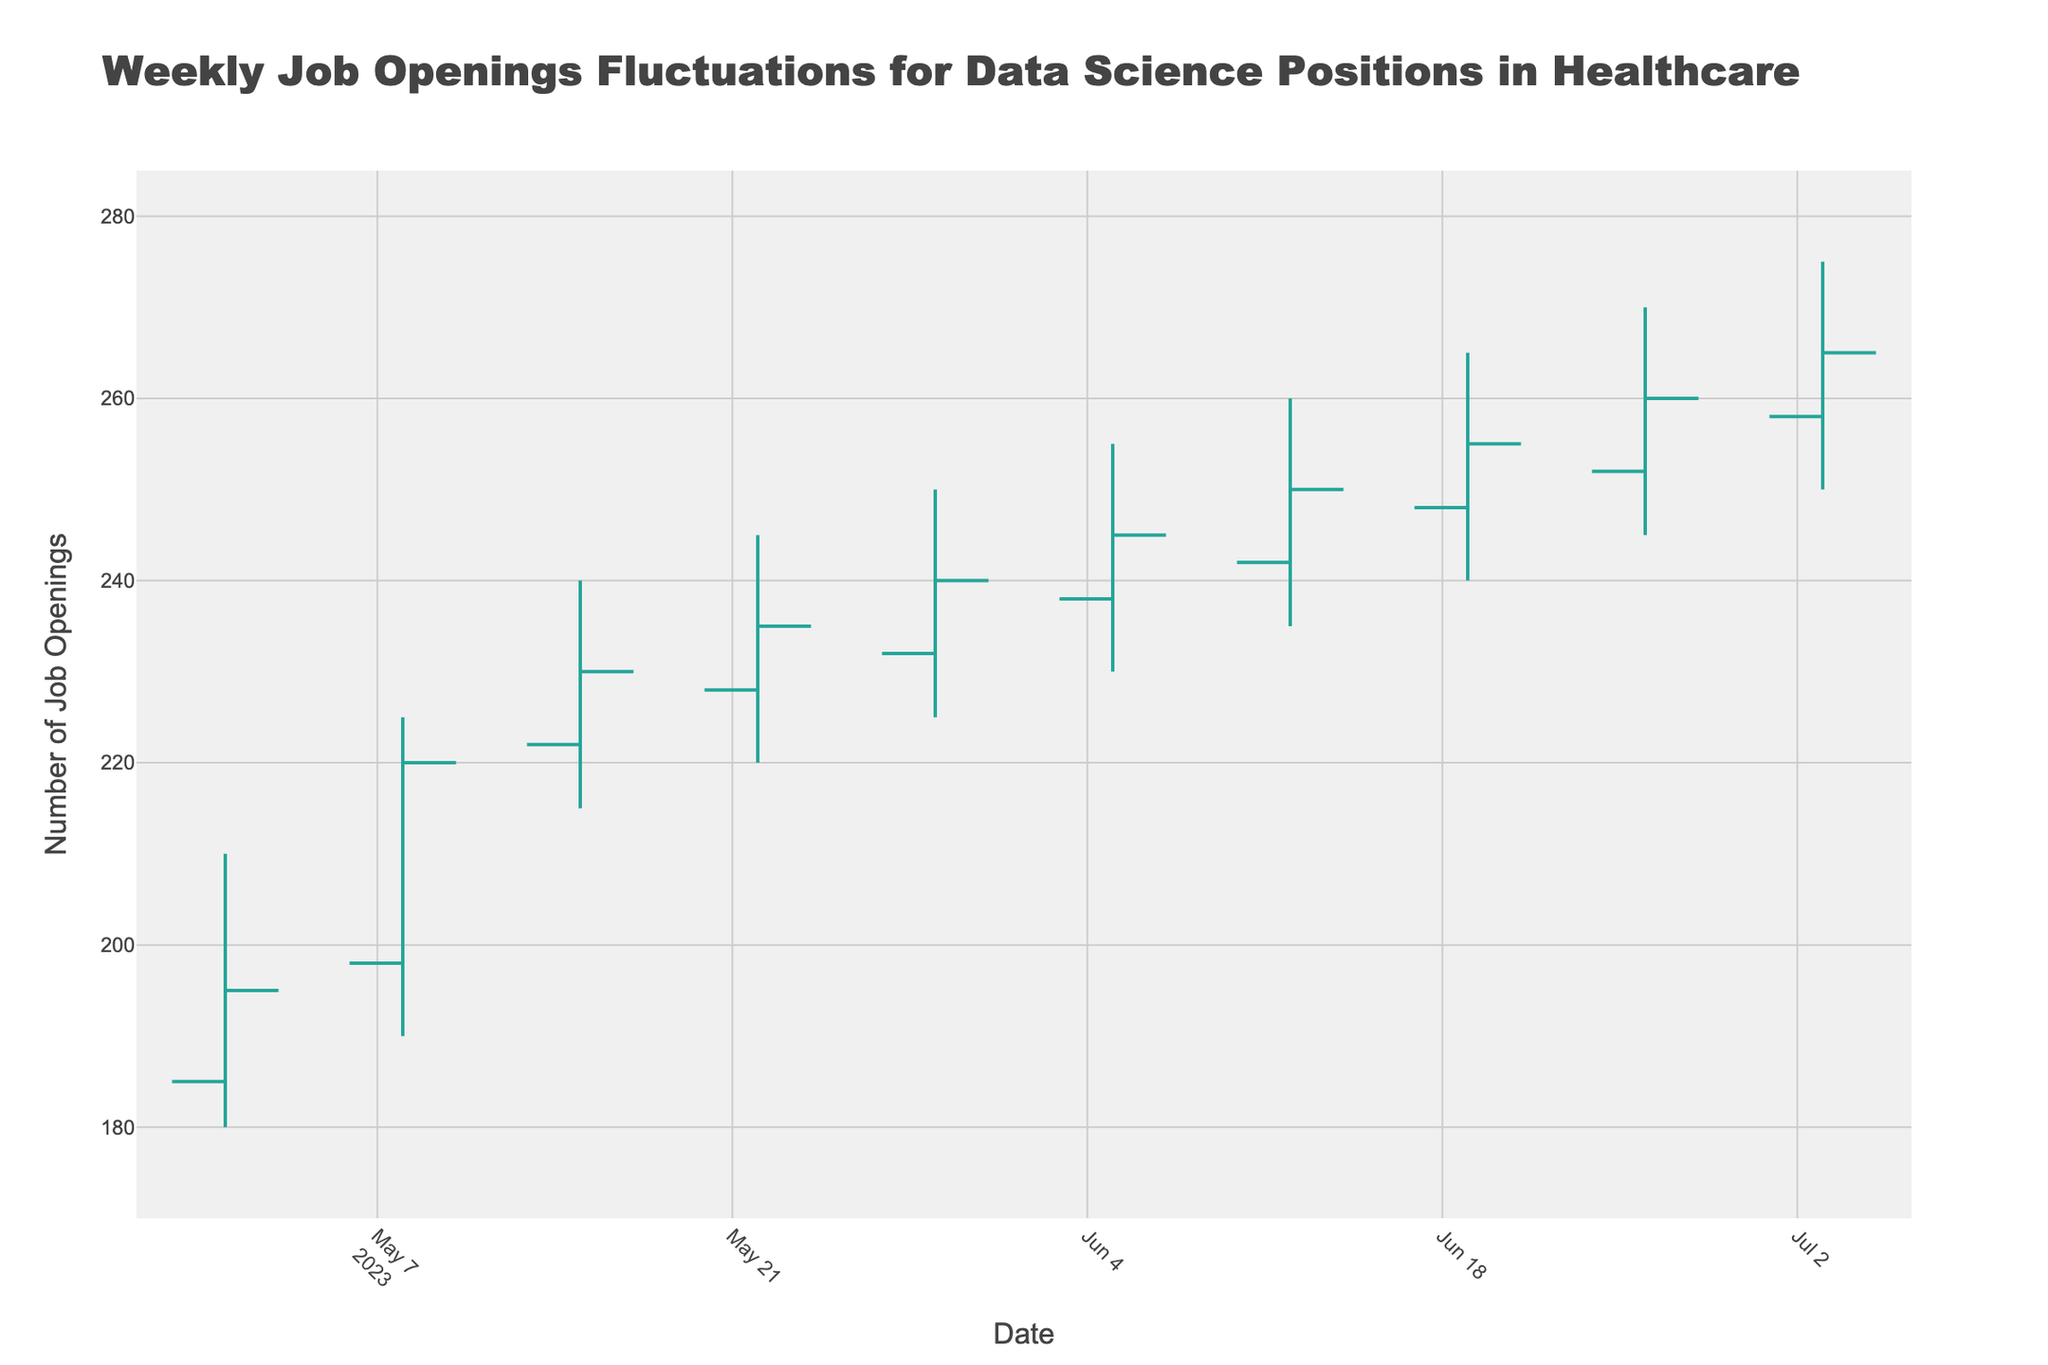how many weeks are visually represented in the figure? There are data points for each week from May 1, 2023, to July 3, 2023. Counting these weeks, we get 10 weekly data points.
Answer: 10 What is the highest number of job openings recorded in any week? The highest number of job openings is represented by the highest point on the vertical axis of the chart. The highest recorded value is 275 job openings on July 3, 2023.
Answer: 275 How is the fill color of increasing and decreasing markers differentiated in the figure? The visual chart uses different line colors for increasing and decreasing values. Increasing values are shown in green, and decreasing values are shown in red.
Answer: Green and Red During which week did the number of job openings have the greatest range? The range is calculated by subtracting the low from the high for each week. The largest range occurs on July 3, 2023, where the high is 275 and the low is 250, giving a range of 25 openings.
Answer: July 3, 2023 By how much did the number of job openings change from the first to the last week represented? The opening value on May 1, 2023, is 185, and the closing value on July 3, 2023, is 265. The change is 265 - 185 = 80 job openings.
Answer: 80 Which week experienced the smallest fluctuation in job openings? Fluctuation can be determined by the smallest difference between high and low values within a single week. The week of May 1, 2023, shows a range of 30 (210 - 180), which is the smallest range in the dataset.
Answer: May 1, 2023 Which week had the highest opening value, and what was that value? The opening values for each week are plotted. The highest opening value is recorded on July 3, 2023, with 258 job openings.
Answer: July 3, 2023 When did the first occurrence of the closing value surpass 250 job openings? The first time the closing value surpasses 250 job openings is observed on June 12, 2023, with a closing value of 250.
Answer: June 12, 2023 What was the median closing value over the period shown in the chart? To find the median, list all closing values in ascending order and find the middle value. The closing values are (195, 220, 230, 235, 240, 245, 250, 255, 260, 265). The median closing value is the average of the 5th and 6th values, which is (240+245)/2 = 242.5.
Answer: 242.5 Comparing May 1, 2023, and June 19, 2023, did the closing value for job openings increase or decrease, and by how much? The closing value on May 1, 2023, is 195, and on June 19, 2023, it is 255. The difference is 255 - 195 = 60 job openings, indicating an increase.
Answer: increased by 60 